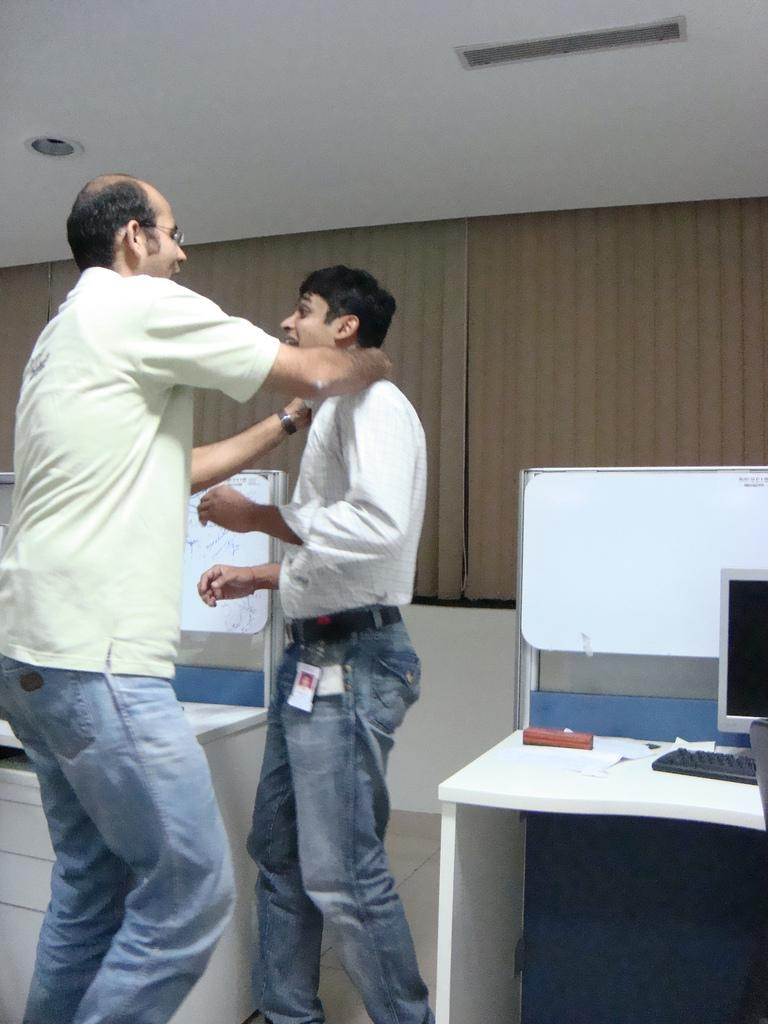How many people are in the image? There are two men in the image. What are the men doing in the image? The men are standing next to a table. What electronic devices are visible in the image? There is a monitor and a keyboard in the image. What can be seen in the background of the image? There is a wall and a ceiling in the background of the image. What type of nerve can be seen in the image? There is no nerve present in the image. What kind of paste is being used by the men in the image? There is no paste visible in the image, and the men are not performing any activity that would involve using paste. 